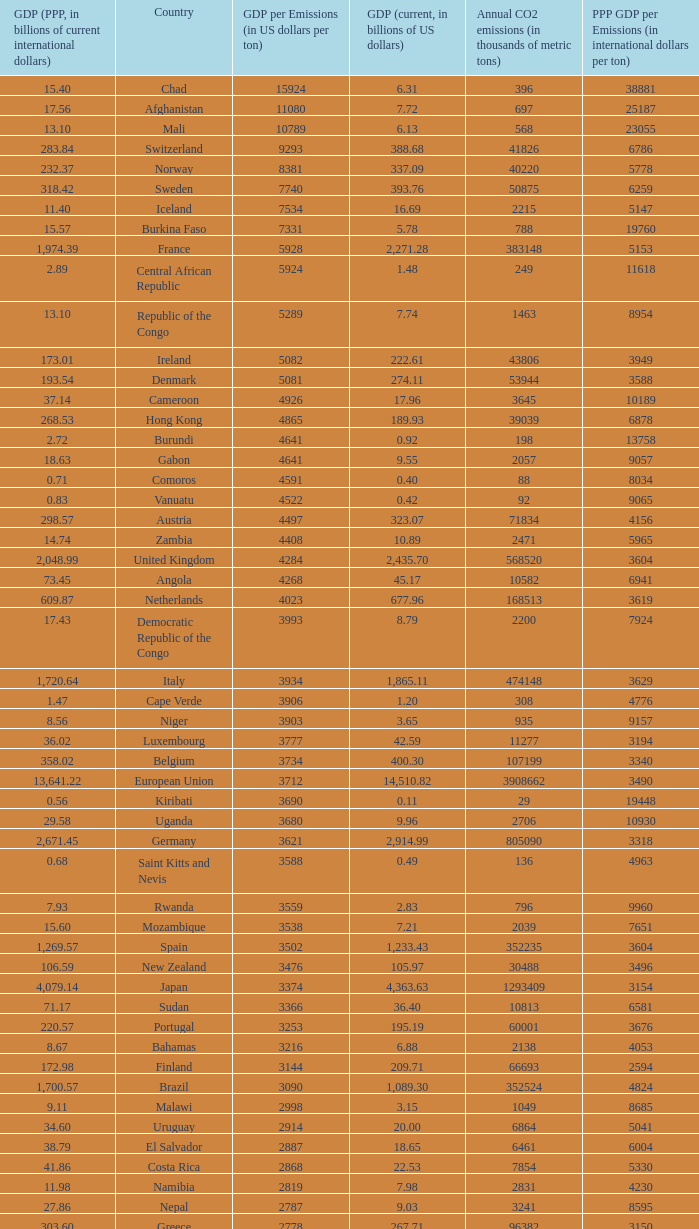When the gdp (ppp, in billions of current international dollars) is 7.93, what is the maximum ppp gdp per emissions (in international dollars per ton)? 9960.0. 